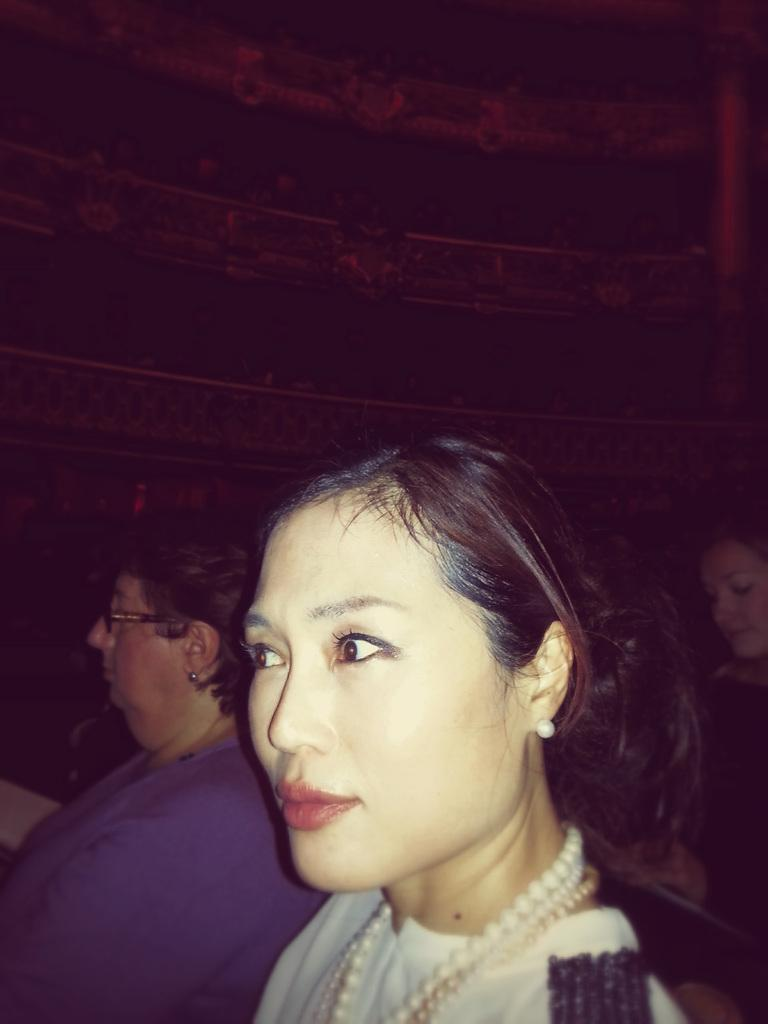How many people are sitting on chairs in the image? There are two people sitting on chairs in the image. Are there any other people visible in the image? Yes, there are other people behind them. What can be seen in the background of the image? There is a wall in the background of the image. What type of tree is growing out of the stone in the image? There is no tree or stone present in the image. 